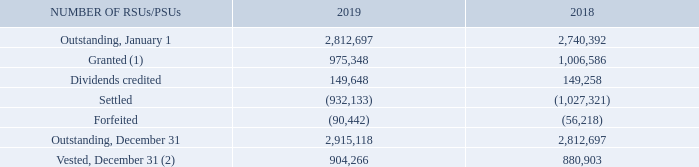RSUs/PSUs
RSUs/PSUs are granted to executives and other eligible employees. The value of an RSU/PSU at the grant date is equal to the value of one BCE common share. Dividends in the form of additional RSUs/PSUs are credited to the participant’s account on each dividend payment date and are equivalent in value to the dividend paid on BCE common shares. Executives and other eligible employees are granted a specific number of RSUs/PSUs for a given performance period based on their position and level of contribution. RSUs/PSUs vest fully after three years of continuous employment from the date of grant and, in certain cases, if performance objectives are met, as determined by the board of directors.
The following table summarizes outstanding RSUs/PSUs at December 31, 2019 and 2018.
(1) The weighted average fair value of the RSUs/PSUs granted was $58 in 2019 and $57 in 2018
(2) The RSUs/PSUs vested on December 31, 2019 were fully settled in February 2020 with BCE common shares and/or DSUs.
What is the weighted average fair value of the RSUs/PSUs granted in 2019? $58. Who are the RSUs/PSUs granted to? Executives and other eligible employees. What conditions determine whether executives and other eligible employees are granted RSUs/PSUs? Position, level of contribution, in certain cases, if performance objectives are met. In which year is the amount of dividends credited larger? 149,648>149,258
Answer: 2019. What is the change in the weighted average fair value of the RSUs/PSUs granted? $58-$57
Answer: 1. What is the average vested amount in 2018 and 2019? (904,266+880,903)/2
Answer: 892584.5. 